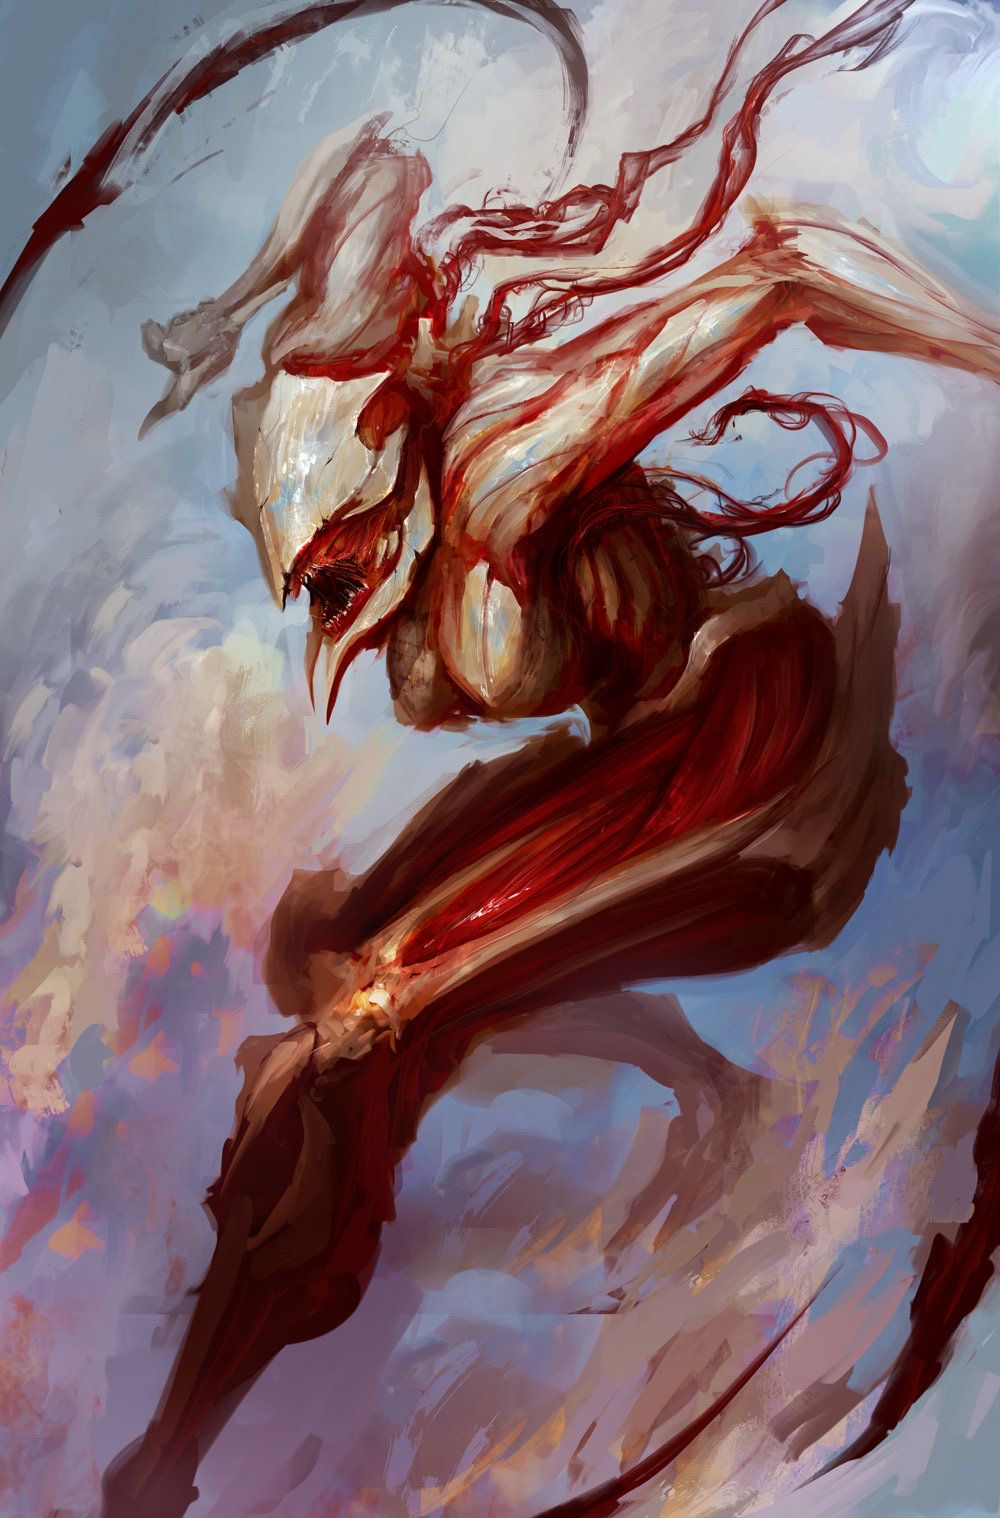go into deep detail with this image, analyze each small detail in this image as well even things that aren’t in your normal data The image is a painting of a creature that appears to be a mix of human and animal. It has the body of a human, but the head of a wolf. The creature is also covered in fur, and has large, sharp claws. It is standing on a rock, and is surrounded by a dark background. The creature is in mid-stride, and appears to be moving quickly. Its muscles are tensed, and its eyes are wide open. The background is dark and stormy, and the creature is illuminated by a single light source.

The painting is done in a realistic style, and the artist has used a variety of techniques to create a sense of depth and realism. The creature is well-lit, and the artist has used a variety of colors to create a sense of contrast. The background is dark and stormy, and the creature is illuminated by a single light source. This creates a sense of drama and suspense, and makes the creature stand out from the background.

The artist has also used a variety of techniques to create a sense of movement. The creature is in mid-stride, and its muscles are tensed. This creates a sense of anticipation and excitement, and makes the viewer feel like they are part of the action. The background is also blurred, which helps to create a sense of speed.

The painting is a powerful and dynamic work of art, and the artist has used a variety of techniques to create a sense of depth, realism, and movement. The creature is a unique and interesting subject, and the painting is sure to leave a lasting impression on the viewer. 